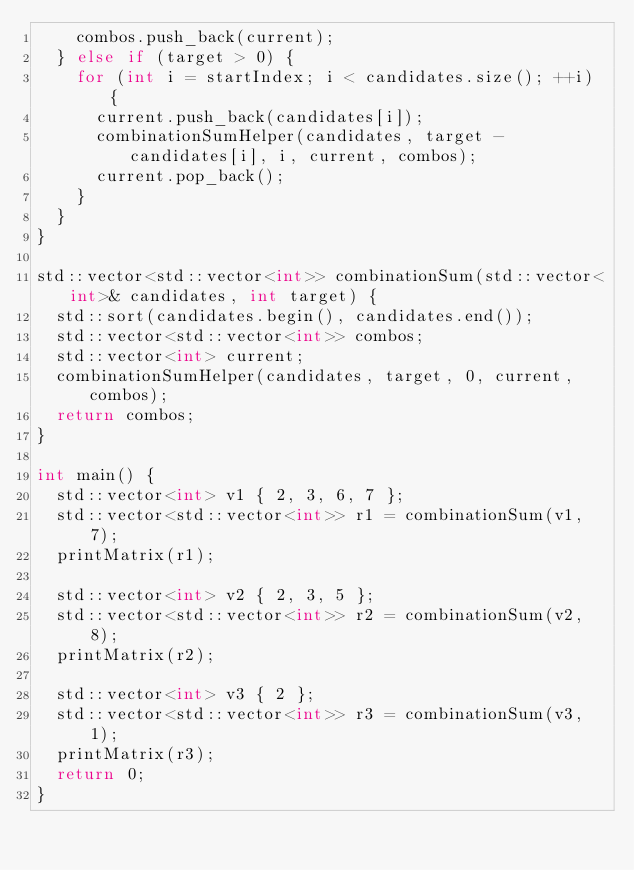Convert code to text. <code><loc_0><loc_0><loc_500><loc_500><_C++_>    combos.push_back(current);
  } else if (target > 0) {
    for (int i = startIndex; i < candidates.size(); ++i) {
      current.push_back(candidates[i]);
      combinationSumHelper(candidates, target - candidates[i], i, current, combos);
      current.pop_back();
    }
  }
}

std::vector<std::vector<int>> combinationSum(std::vector<int>& candidates, int target) {
  std::sort(candidates.begin(), candidates.end());
  std::vector<std::vector<int>> combos;
  std::vector<int> current;
  combinationSumHelper(candidates, target, 0, current, combos);
  return combos;
}

int main() {
  std::vector<int> v1 { 2, 3, 6, 7 };
  std::vector<std::vector<int>> r1 = combinationSum(v1, 7);
  printMatrix(r1);

  std::vector<int> v2 { 2, 3, 5 };
  std::vector<std::vector<int>> r2 = combinationSum(v2, 8);
  printMatrix(r2);

  std::vector<int> v3 { 2 };
  std::vector<std::vector<int>> r3 = combinationSum(v3, 1);
  printMatrix(r3);
  return 0;
}
</code> 